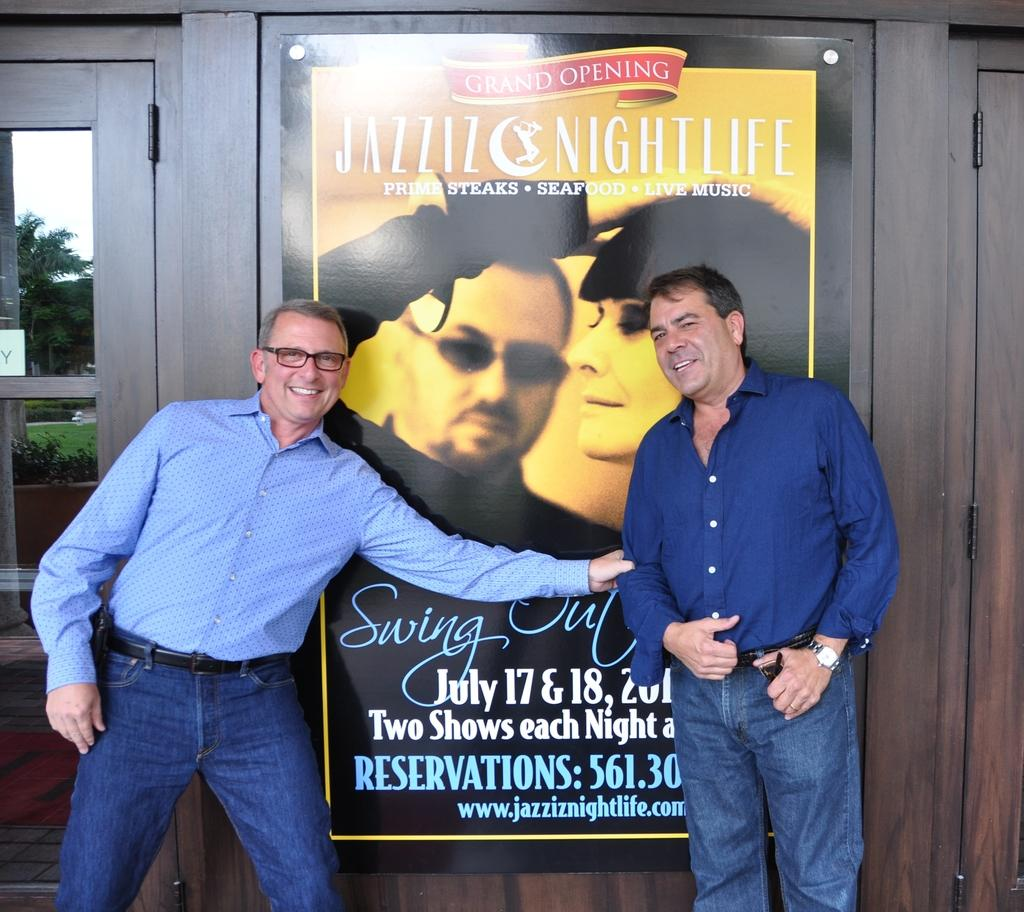How many people are present in the image? There are two persons standing in the image. What can be seen in the background of the image? There is a poster and a wooden wall in the background of the image. What is the material of the door on the left side of the image? The door on the left side of the image is made of glass. What type of discussion is taking place between the babies in the image? There are no babies present in the image, so no discussion can be observed. What is the base of the structure supporting the poster in the image? The provided facts do not mention a base for the poster, so it cannot be determined from the image. 